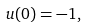Convert formula to latex. <formula><loc_0><loc_0><loc_500><loc_500>u ( 0 ) = - 1 ,</formula> 